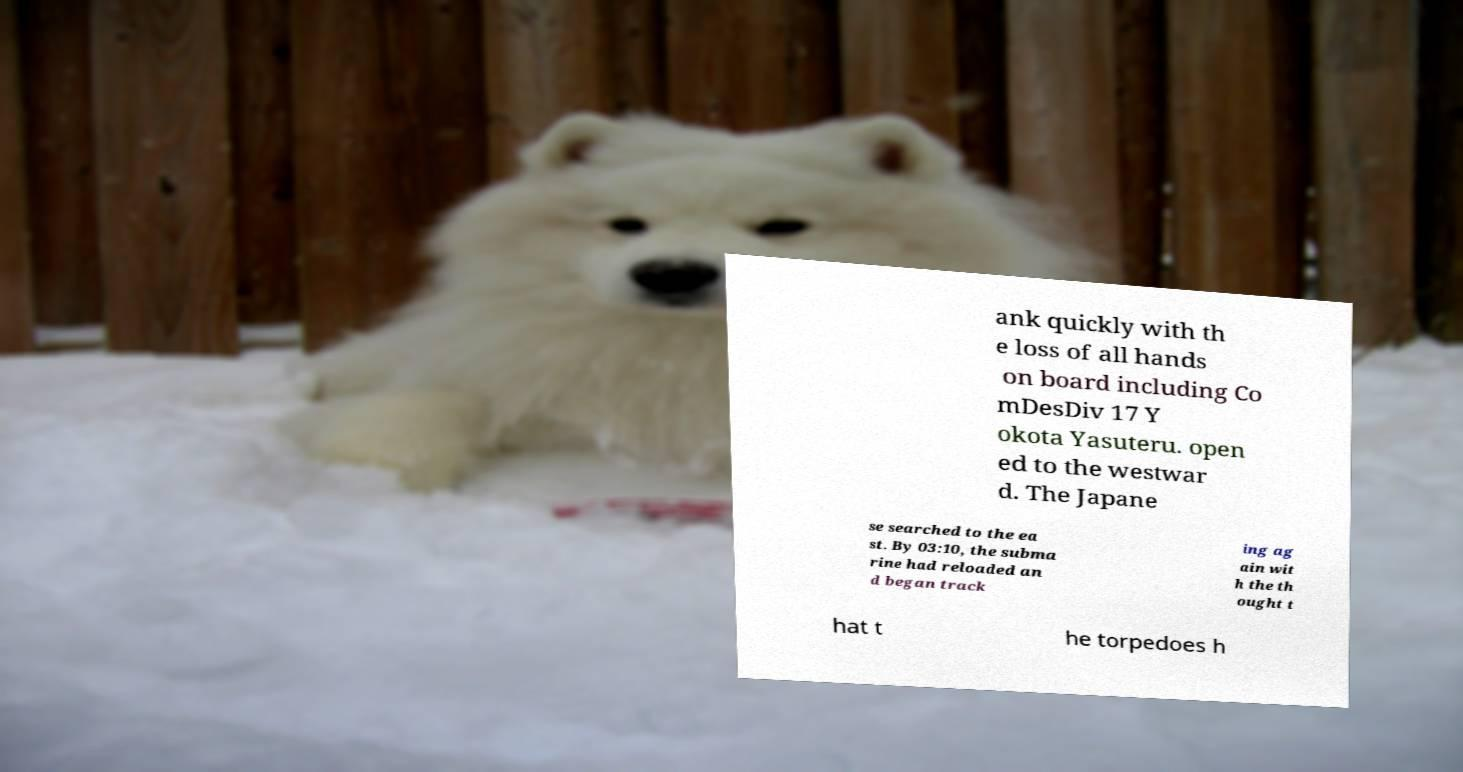There's text embedded in this image that I need extracted. Can you transcribe it verbatim? ank quickly with th e loss of all hands on board including Co mDesDiv 17 Y okota Yasuteru. open ed to the westwar d. The Japane se searched to the ea st. By 03:10, the subma rine had reloaded an d began track ing ag ain wit h the th ought t hat t he torpedoes h 